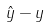<formula> <loc_0><loc_0><loc_500><loc_500>\hat { y } - y</formula> 